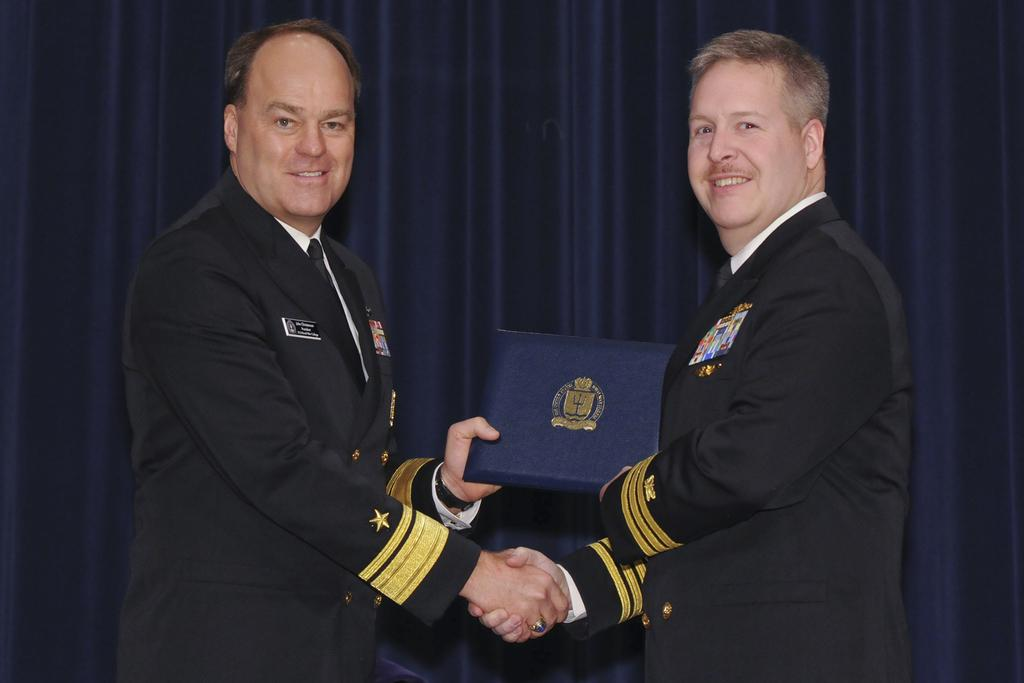How many people are present in the image? There are two people in the image. What can be seen in the background of the image? There is a curtain in the image. Can you describe one of the people in the image? One of the people is a man. What is the man holding in the image? The man is holding a book. What type of smoke is coming from the jar in the image? There is no jar or smoke present in the image. What is the range of the objects in the image? The range of the objects in the image cannot be determined without additional information about the size and distance of the objects. 